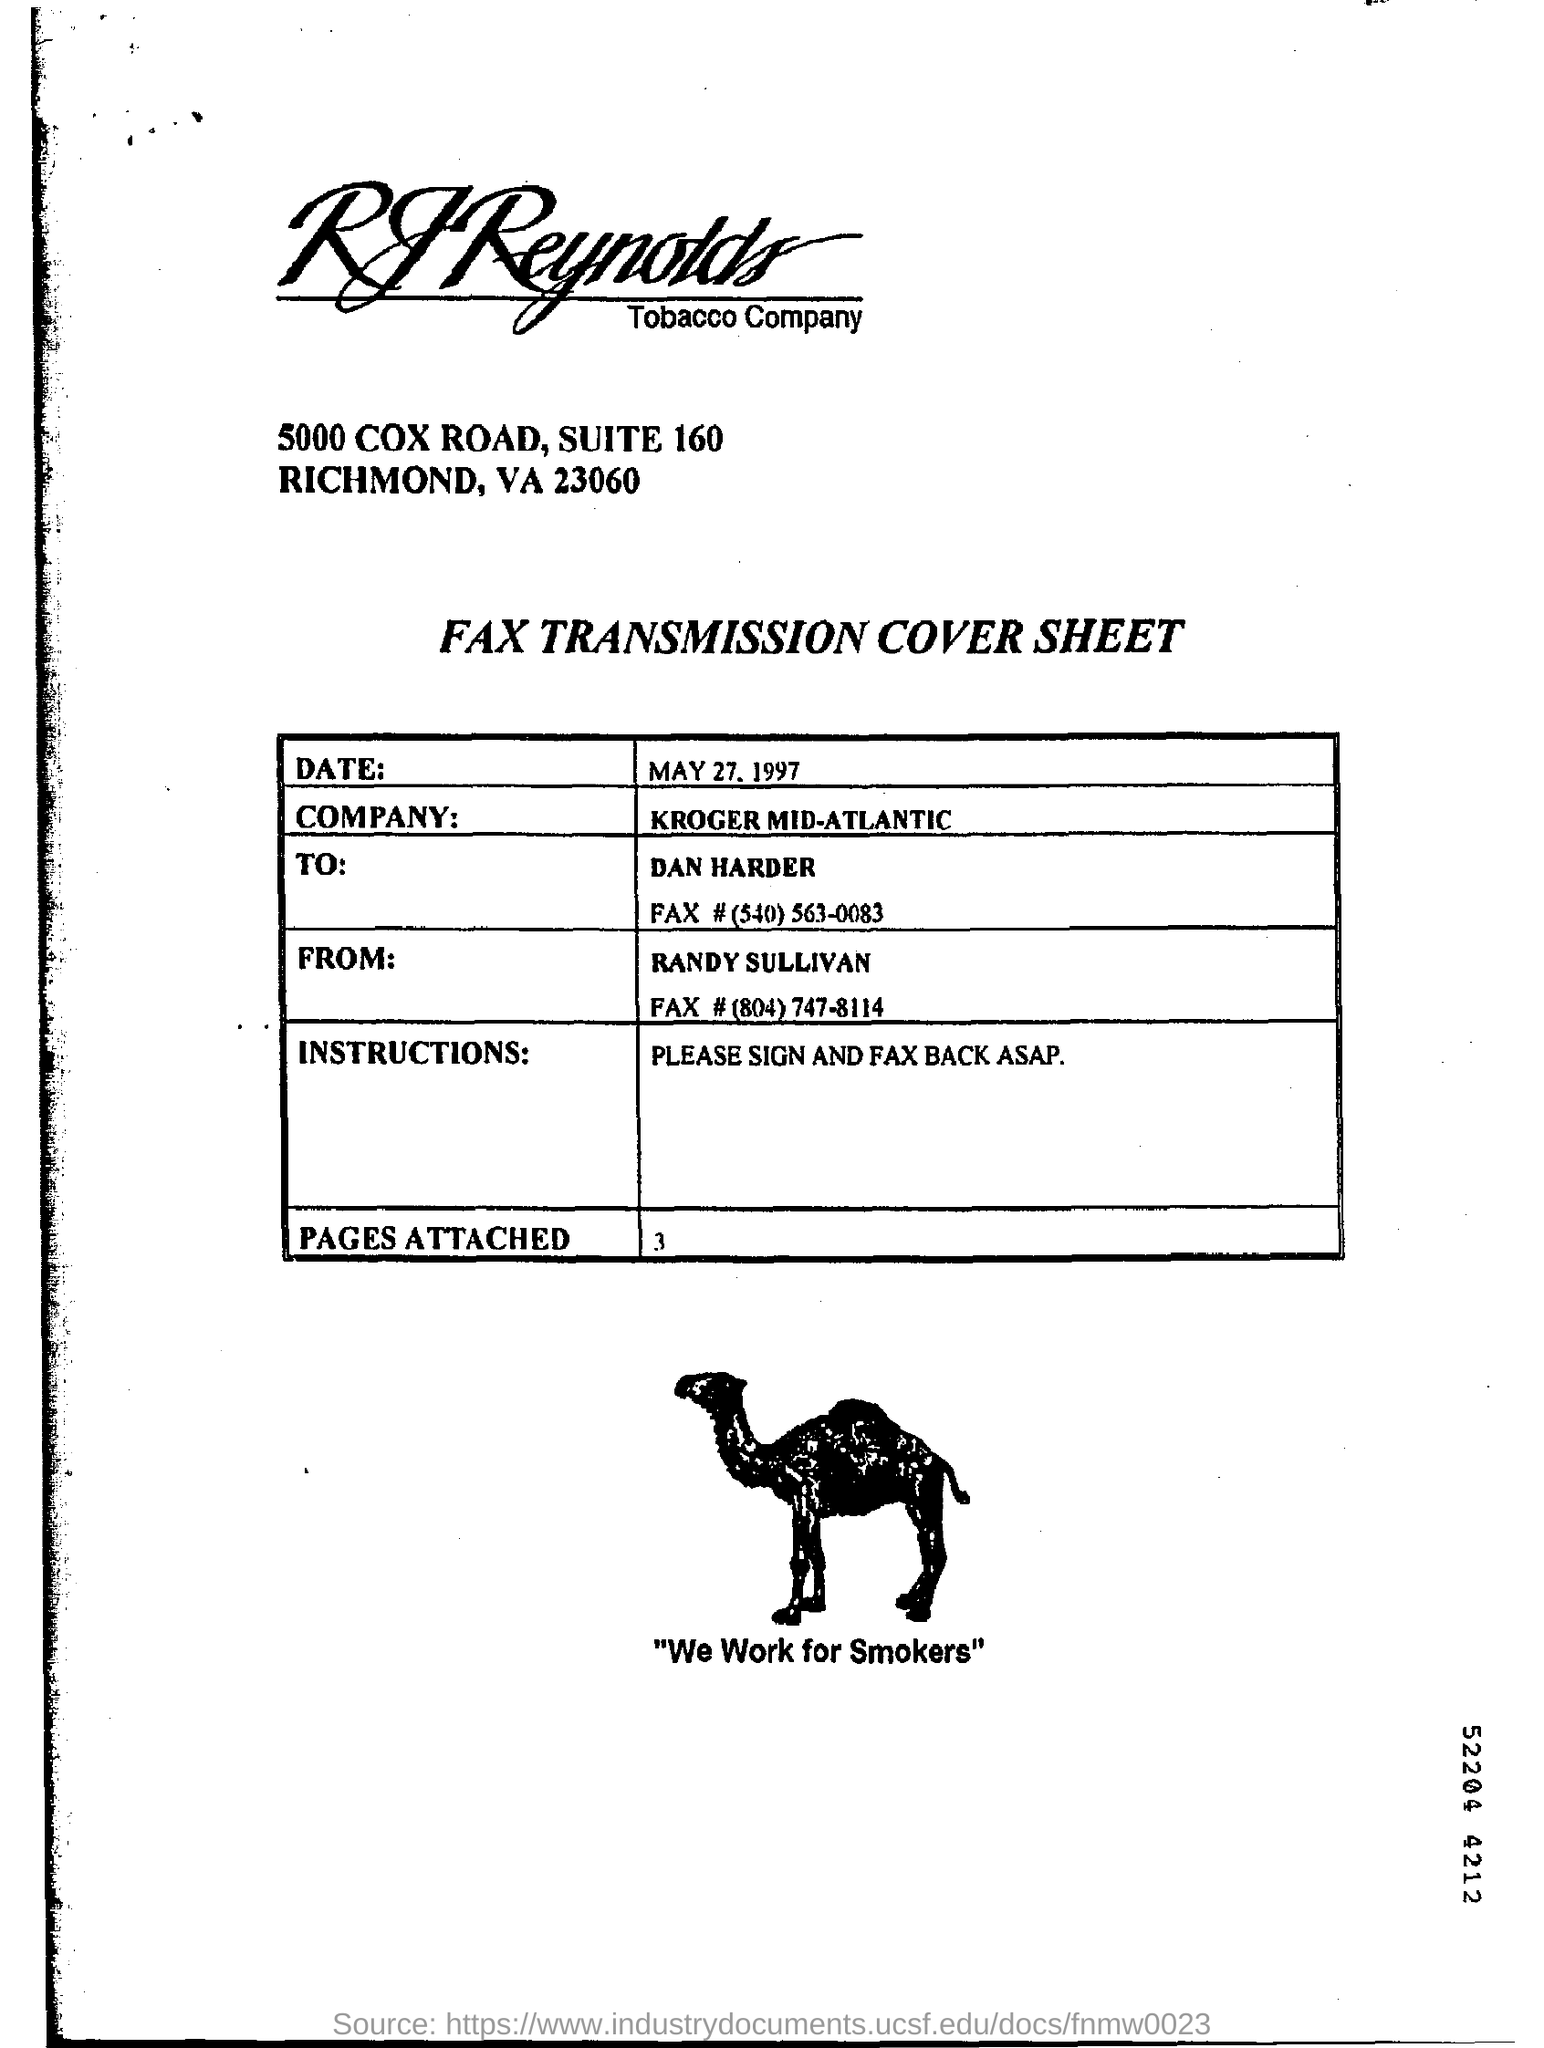What is the date?
Keep it short and to the point. May 27, 1997. What is the name of company?
Offer a terse response. KROGER MID-ATLANTIC. What is the instructions?
Keep it short and to the point. Please sign and fax back asap. 